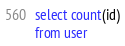<code> <loc_0><loc_0><loc_500><loc_500><_SQL_>select count(id)
from user
</code> 